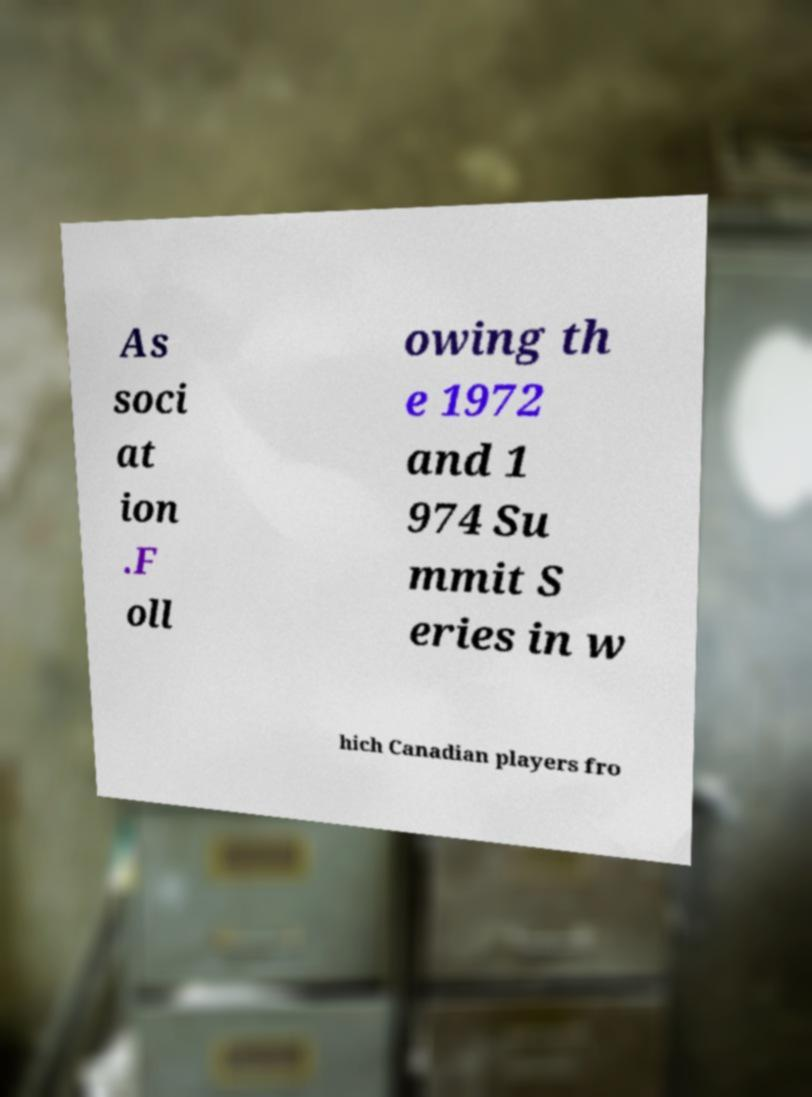What messages or text are displayed in this image? I need them in a readable, typed format. As soci at ion .F oll owing th e 1972 and 1 974 Su mmit S eries in w hich Canadian players fro 